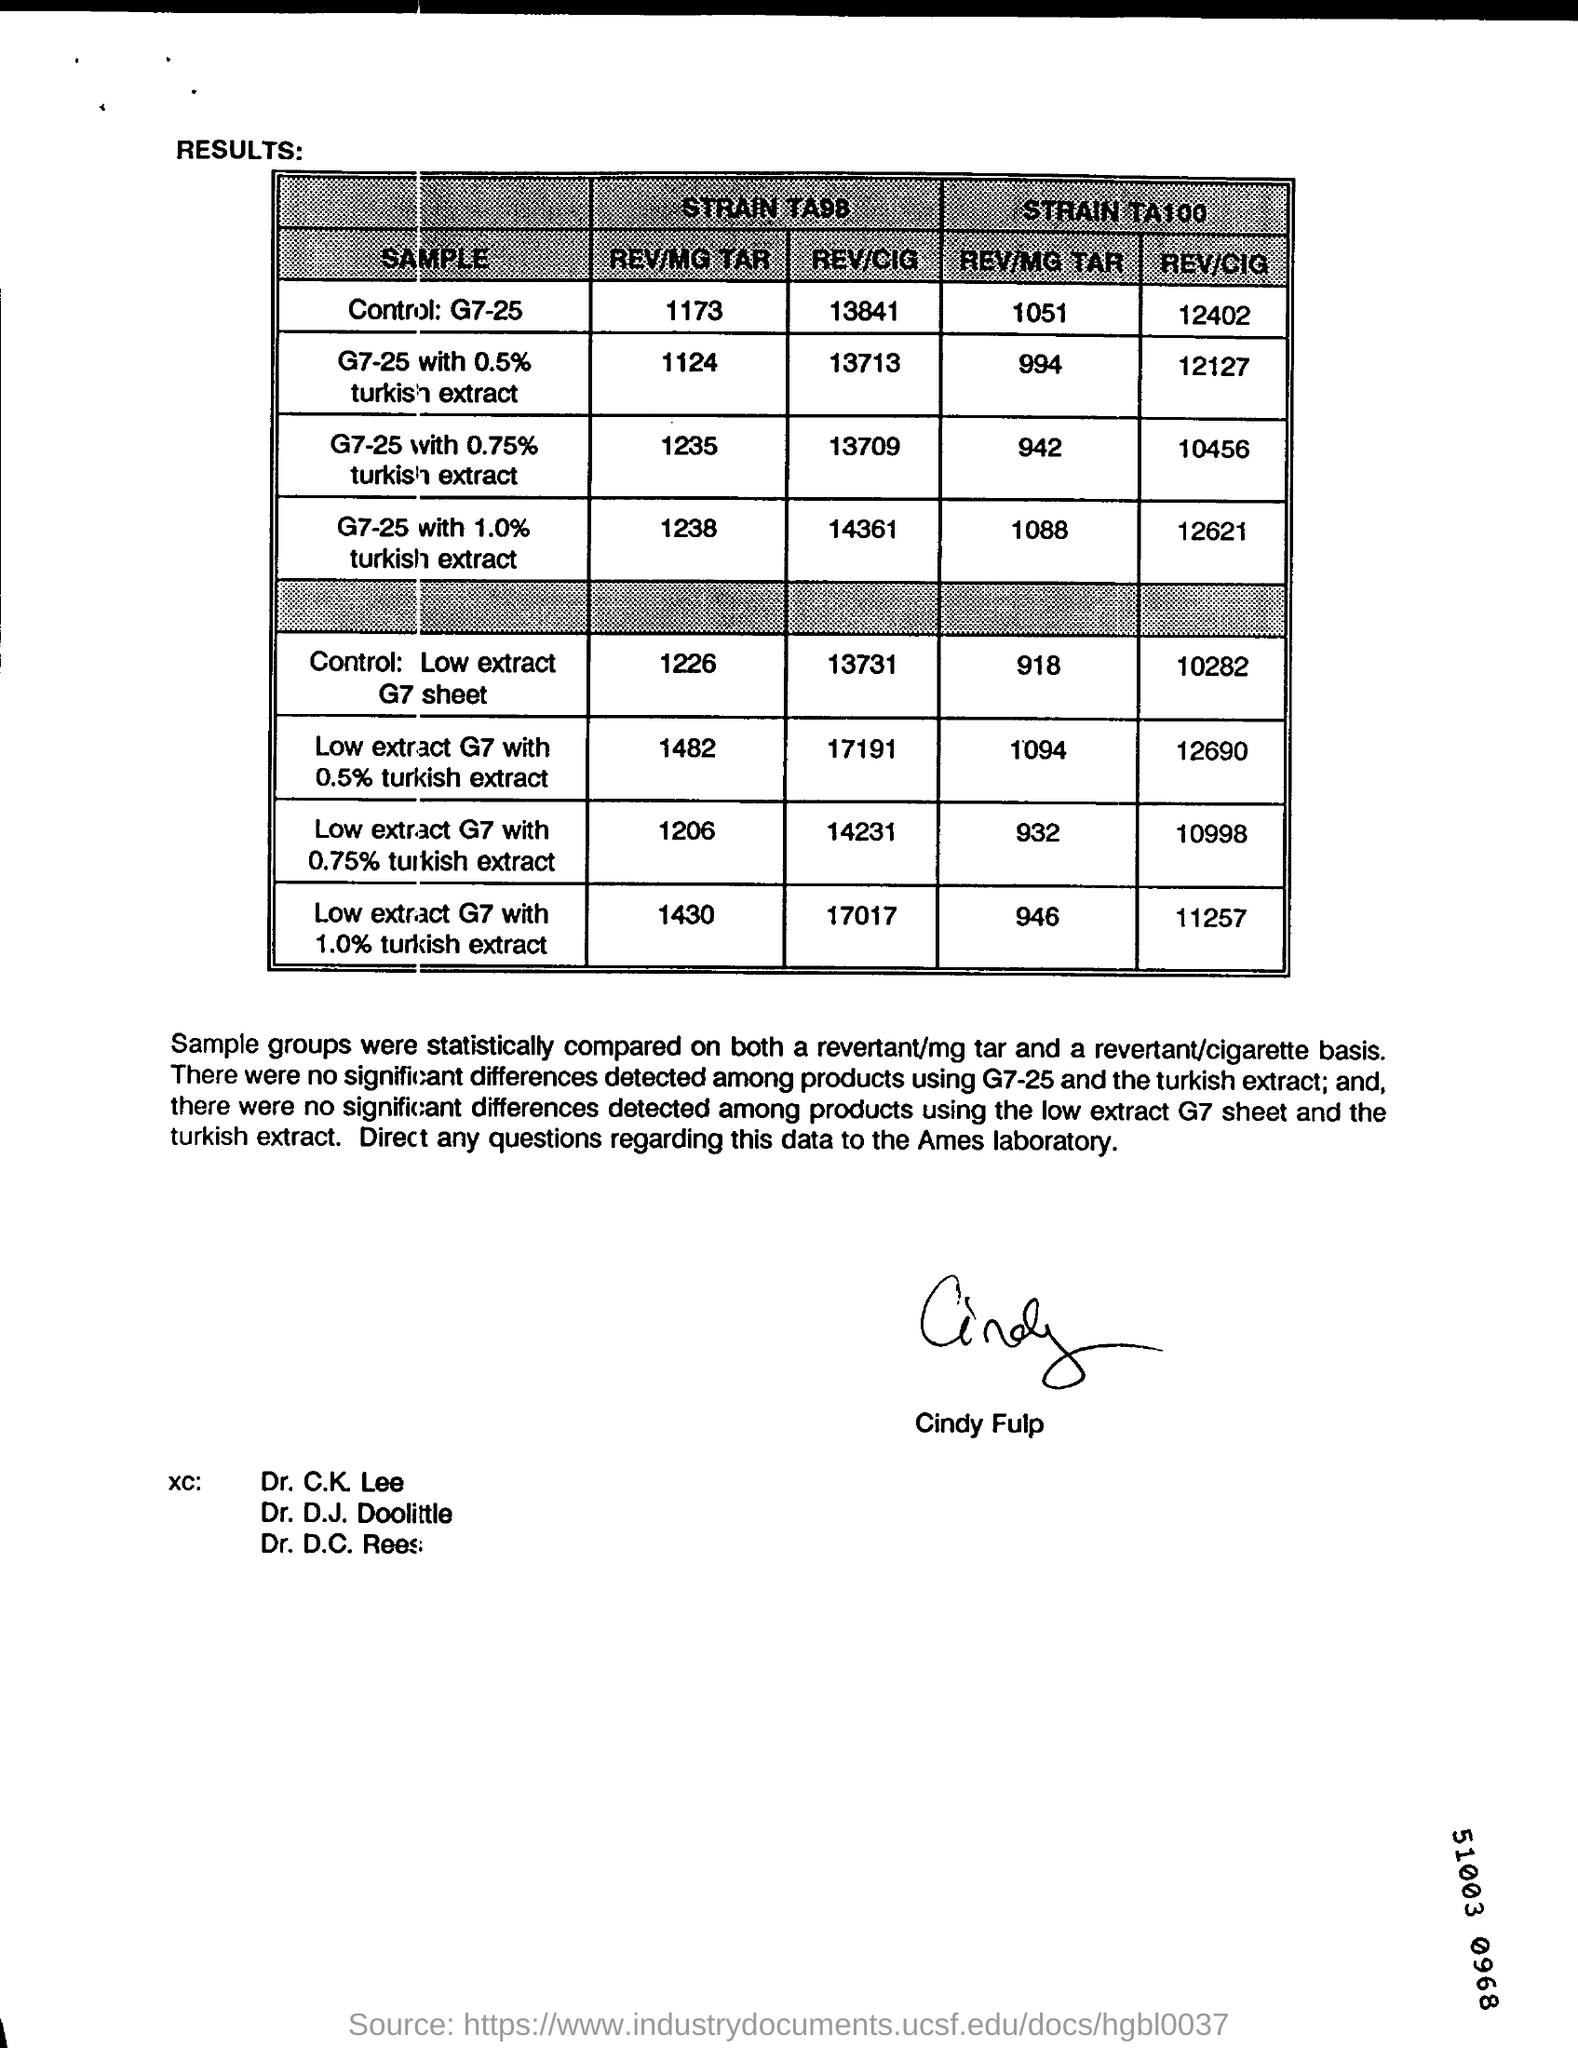Identify some key points in this picture. The sample of the strain STRAIN TA100 was found to have a REV/MG TAR 1094 value of (REDACTED), with a low extract G7 measurement of (REDACTED) and a 0.5% Turkish extract. The STRAIN TA100, REV/CIG of G7-25 with 1.0% turkish extract is 12621. 